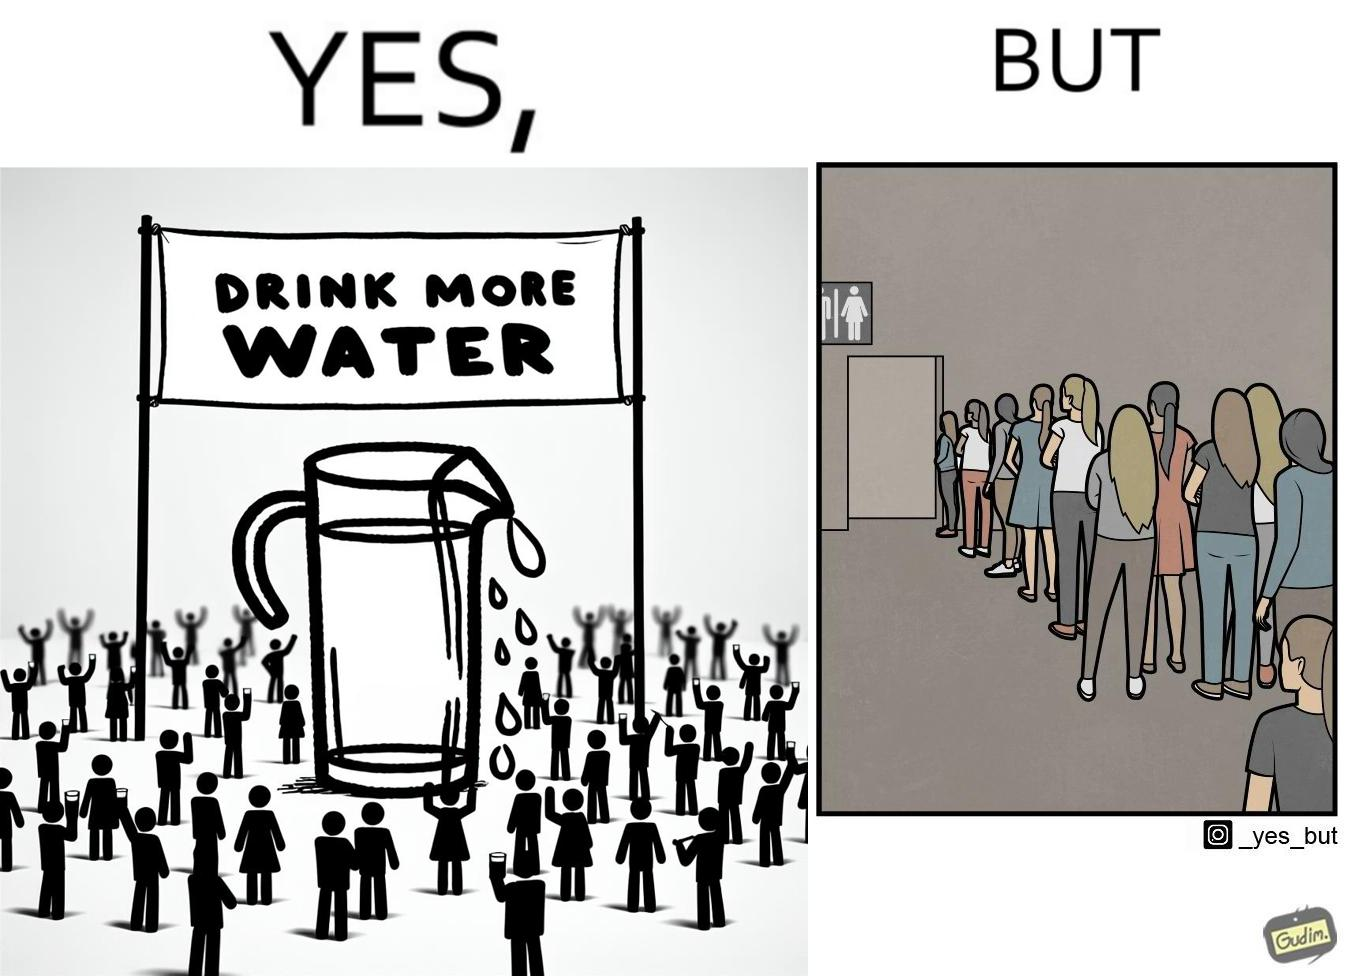Explain why this image is satirical. The image is ironical, as the message "Drink more water" is meant to improve health, but in turn, it would lead to longer queues in front of public toilets, leading to people holding urine for longer periods, in turn leading to deterioration in health. 